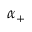Convert formula to latex. <formula><loc_0><loc_0><loc_500><loc_500>\alpha _ { + }</formula> 